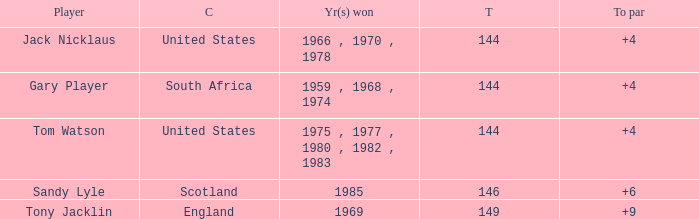What player had a To par smaller than 9 and won in 1985? Sandy Lyle. 